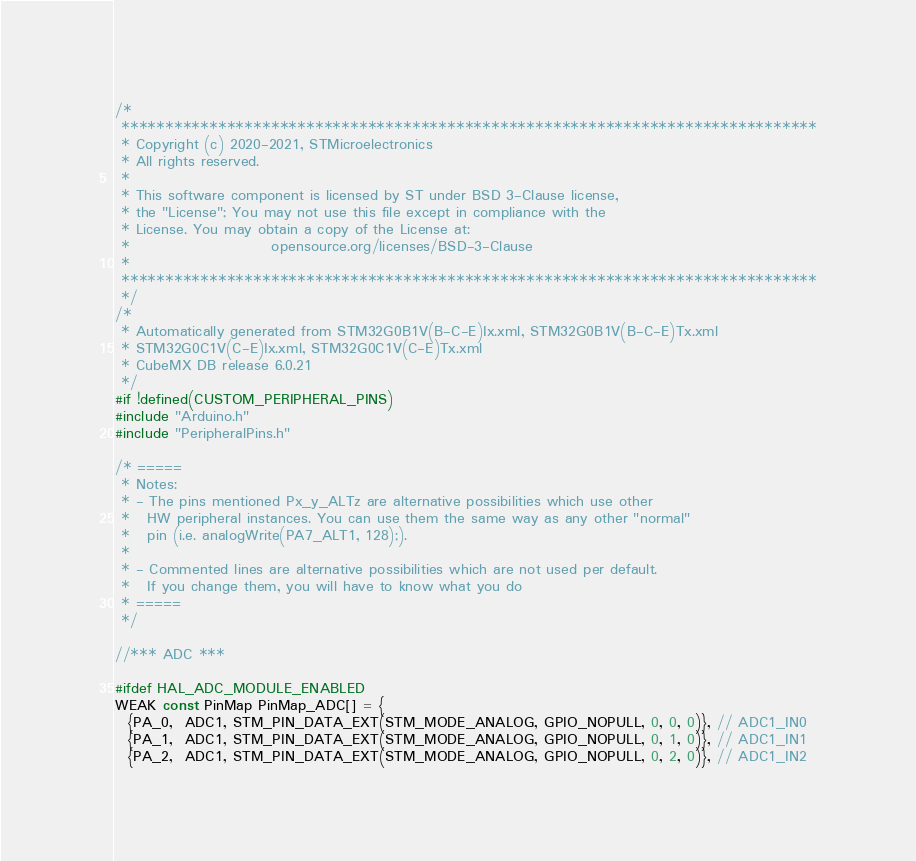Convert code to text. <code><loc_0><loc_0><loc_500><loc_500><_C_>/*
 *******************************************************************************
 * Copyright (c) 2020-2021, STMicroelectronics
 * All rights reserved.
 *
 * This software component is licensed by ST under BSD 3-Clause license,
 * the "License"; You may not use this file except in compliance with the
 * License. You may obtain a copy of the License at:
 *                        opensource.org/licenses/BSD-3-Clause
 *
 *******************************************************************************
 */
/*
 * Automatically generated from STM32G0B1V(B-C-E)Ix.xml, STM32G0B1V(B-C-E)Tx.xml
 * STM32G0C1V(C-E)Ix.xml, STM32G0C1V(C-E)Tx.xml
 * CubeMX DB release 6.0.21
 */
#if !defined(CUSTOM_PERIPHERAL_PINS)
#include "Arduino.h"
#include "PeripheralPins.h"

/* =====
 * Notes:
 * - The pins mentioned Px_y_ALTz are alternative possibilities which use other
 *   HW peripheral instances. You can use them the same way as any other "normal"
 *   pin (i.e. analogWrite(PA7_ALT1, 128);).
 *
 * - Commented lines are alternative possibilities which are not used per default.
 *   If you change them, you will have to know what you do
 * =====
 */

//*** ADC ***

#ifdef HAL_ADC_MODULE_ENABLED
WEAK const PinMap PinMap_ADC[] = {
  {PA_0,  ADC1, STM_PIN_DATA_EXT(STM_MODE_ANALOG, GPIO_NOPULL, 0, 0, 0)}, // ADC1_IN0
  {PA_1,  ADC1, STM_PIN_DATA_EXT(STM_MODE_ANALOG, GPIO_NOPULL, 0, 1, 0)}, // ADC1_IN1
  {PA_2,  ADC1, STM_PIN_DATA_EXT(STM_MODE_ANALOG, GPIO_NOPULL, 0, 2, 0)}, // ADC1_IN2</code> 